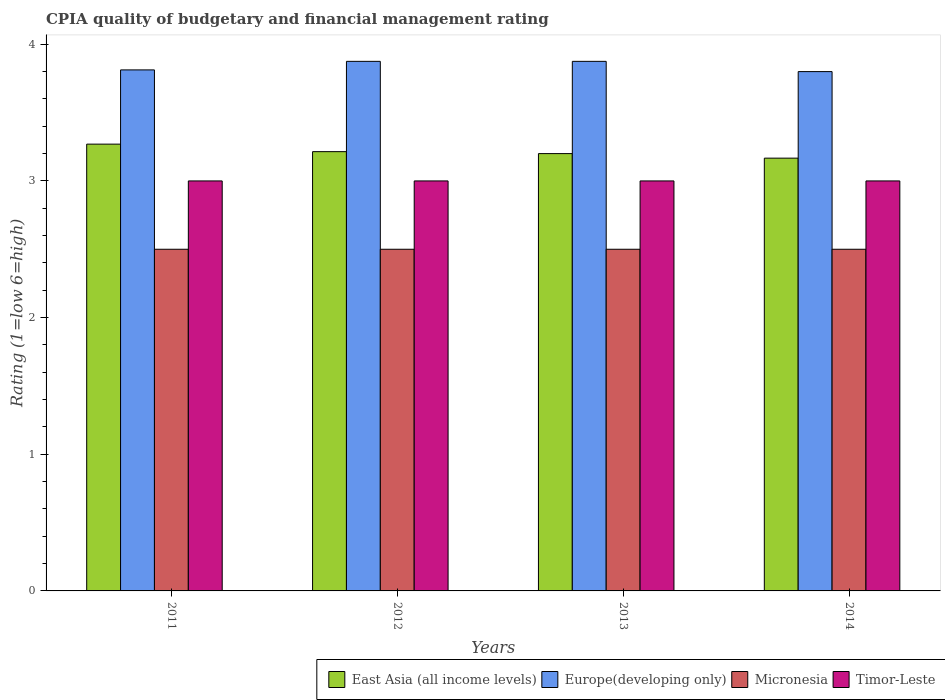How many groups of bars are there?
Offer a very short reply. 4. How many bars are there on the 1st tick from the left?
Offer a terse response. 4. What is the label of the 2nd group of bars from the left?
Offer a terse response. 2012. In how many cases, is the number of bars for a given year not equal to the number of legend labels?
Offer a very short reply. 0. What is the CPIA rating in East Asia (all income levels) in 2011?
Keep it short and to the point. 3.27. Across all years, what is the maximum CPIA rating in Micronesia?
Give a very brief answer. 2.5. Across all years, what is the minimum CPIA rating in Micronesia?
Give a very brief answer. 2.5. In which year was the CPIA rating in East Asia (all income levels) maximum?
Your answer should be compact. 2011. In which year was the CPIA rating in Timor-Leste minimum?
Make the answer very short. 2011. What is the total CPIA rating in Europe(developing only) in the graph?
Offer a terse response. 15.36. What is the difference between the CPIA rating in East Asia (all income levels) in 2014 and the CPIA rating in Timor-Leste in 2012?
Give a very brief answer. 0.17. What is the average CPIA rating in Europe(developing only) per year?
Ensure brevity in your answer.  3.84. In how many years, is the CPIA rating in Timor-Leste greater than 0.2?
Offer a very short reply. 4. What is the ratio of the CPIA rating in East Asia (all income levels) in 2012 to that in 2014?
Offer a terse response. 1.02. Is the CPIA rating in Micronesia in 2012 less than that in 2013?
Offer a very short reply. No. Is the difference between the CPIA rating in Europe(developing only) in 2012 and 2014 greater than the difference between the CPIA rating in Timor-Leste in 2012 and 2014?
Your answer should be compact. Yes. What is the difference between the highest and the lowest CPIA rating in East Asia (all income levels)?
Provide a succinct answer. 0.1. In how many years, is the CPIA rating in Europe(developing only) greater than the average CPIA rating in Europe(developing only) taken over all years?
Offer a terse response. 2. What does the 2nd bar from the left in 2011 represents?
Give a very brief answer. Europe(developing only). What does the 3rd bar from the right in 2012 represents?
Offer a terse response. Europe(developing only). Is it the case that in every year, the sum of the CPIA rating in Timor-Leste and CPIA rating in Micronesia is greater than the CPIA rating in East Asia (all income levels)?
Your response must be concise. Yes. How many bars are there?
Your response must be concise. 16. What is the difference between two consecutive major ticks on the Y-axis?
Your answer should be very brief. 1. Does the graph contain grids?
Offer a very short reply. No. How many legend labels are there?
Provide a succinct answer. 4. What is the title of the graph?
Give a very brief answer. CPIA quality of budgetary and financial management rating. What is the label or title of the X-axis?
Your response must be concise. Years. What is the label or title of the Y-axis?
Your response must be concise. Rating (1=low 6=high). What is the Rating (1=low 6=high) in East Asia (all income levels) in 2011?
Keep it short and to the point. 3.27. What is the Rating (1=low 6=high) of Europe(developing only) in 2011?
Ensure brevity in your answer.  3.81. What is the Rating (1=low 6=high) in East Asia (all income levels) in 2012?
Keep it short and to the point. 3.21. What is the Rating (1=low 6=high) of Europe(developing only) in 2012?
Offer a very short reply. 3.88. What is the Rating (1=low 6=high) of Timor-Leste in 2012?
Your answer should be compact. 3. What is the Rating (1=low 6=high) of Europe(developing only) in 2013?
Your response must be concise. 3.88. What is the Rating (1=low 6=high) of East Asia (all income levels) in 2014?
Keep it short and to the point. 3.17. What is the Rating (1=low 6=high) of Europe(developing only) in 2014?
Give a very brief answer. 3.8. What is the Rating (1=low 6=high) in Micronesia in 2014?
Provide a succinct answer. 2.5. What is the Rating (1=low 6=high) in Timor-Leste in 2014?
Your answer should be very brief. 3. Across all years, what is the maximum Rating (1=low 6=high) of East Asia (all income levels)?
Ensure brevity in your answer.  3.27. Across all years, what is the maximum Rating (1=low 6=high) in Europe(developing only)?
Offer a terse response. 3.88. Across all years, what is the maximum Rating (1=low 6=high) in Micronesia?
Ensure brevity in your answer.  2.5. Across all years, what is the maximum Rating (1=low 6=high) of Timor-Leste?
Make the answer very short. 3. Across all years, what is the minimum Rating (1=low 6=high) in East Asia (all income levels)?
Your answer should be very brief. 3.17. Across all years, what is the minimum Rating (1=low 6=high) in Europe(developing only)?
Your answer should be very brief. 3.8. What is the total Rating (1=low 6=high) in East Asia (all income levels) in the graph?
Provide a short and direct response. 12.85. What is the total Rating (1=low 6=high) of Europe(developing only) in the graph?
Offer a terse response. 15.36. What is the total Rating (1=low 6=high) in Micronesia in the graph?
Offer a very short reply. 10. What is the total Rating (1=low 6=high) of Timor-Leste in the graph?
Provide a succinct answer. 12. What is the difference between the Rating (1=low 6=high) of East Asia (all income levels) in 2011 and that in 2012?
Ensure brevity in your answer.  0.05. What is the difference between the Rating (1=low 6=high) of Europe(developing only) in 2011 and that in 2012?
Your answer should be very brief. -0.06. What is the difference between the Rating (1=low 6=high) of Micronesia in 2011 and that in 2012?
Make the answer very short. 0. What is the difference between the Rating (1=low 6=high) of East Asia (all income levels) in 2011 and that in 2013?
Ensure brevity in your answer.  0.07. What is the difference between the Rating (1=low 6=high) in Europe(developing only) in 2011 and that in 2013?
Your response must be concise. -0.06. What is the difference between the Rating (1=low 6=high) of Micronesia in 2011 and that in 2013?
Offer a very short reply. 0. What is the difference between the Rating (1=low 6=high) in East Asia (all income levels) in 2011 and that in 2014?
Offer a very short reply. 0.1. What is the difference between the Rating (1=low 6=high) in Europe(developing only) in 2011 and that in 2014?
Your answer should be very brief. 0.01. What is the difference between the Rating (1=low 6=high) of Micronesia in 2011 and that in 2014?
Offer a very short reply. 0. What is the difference between the Rating (1=low 6=high) of East Asia (all income levels) in 2012 and that in 2013?
Keep it short and to the point. 0.01. What is the difference between the Rating (1=low 6=high) of Micronesia in 2012 and that in 2013?
Provide a succinct answer. 0. What is the difference between the Rating (1=low 6=high) of Timor-Leste in 2012 and that in 2013?
Provide a succinct answer. 0. What is the difference between the Rating (1=low 6=high) of East Asia (all income levels) in 2012 and that in 2014?
Offer a terse response. 0.05. What is the difference between the Rating (1=low 6=high) in Europe(developing only) in 2012 and that in 2014?
Ensure brevity in your answer.  0.07. What is the difference between the Rating (1=low 6=high) in Europe(developing only) in 2013 and that in 2014?
Your response must be concise. 0.07. What is the difference between the Rating (1=low 6=high) in East Asia (all income levels) in 2011 and the Rating (1=low 6=high) in Europe(developing only) in 2012?
Provide a short and direct response. -0.61. What is the difference between the Rating (1=low 6=high) in East Asia (all income levels) in 2011 and the Rating (1=low 6=high) in Micronesia in 2012?
Your answer should be very brief. 0.77. What is the difference between the Rating (1=low 6=high) in East Asia (all income levels) in 2011 and the Rating (1=low 6=high) in Timor-Leste in 2012?
Provide a short and direct response. 0.27. What is the difference between the Rating (1=low 6=high) of Europe(developing only) in 2011 and the Rating (1=low 6=high) of Micronesia in 2012?
Offer a very short reply. 1.31. What is the difference between the Rating (1=low 6=high) in Europe(developing only) in 2011 and the Rating (1=low 6=high) in Timor-Leste in 2012?
Keep it short and to the point. 0.81. What is the difference between the Rating (1=low 6=high) of East Asia (all income levels) in 2011 and the Rating (1=low 6=high) of Europe(developing only) in 2013?
Give a very brief answer. -0.61. What is the difference between the Rating (1=low 6=high) in East Asia (all income levels) in 2011 and the Rating (1=low 6=high) in Micronesia in 2013?
Your answer should be very brief. 0.77. What is the difference between the Rating (1=low 6=high) in East Asia (all income levels) in 2011 and the Rating (1=low 6=high) in Timor-Leste in 2013?
Give a very brief answer. 0.27. What is the difference between the Rating (1=low 6=high) of Europe(developing only) in 2011 and the Rating (1=low 6=high) of Micronesia in 2013?
Your response must be concise. 1.31. What is the difference between the Rating (1=low 6=high) of Europe(developing only) in 2011 and the Rating (1=low 6=high) of Timor-Leste in 2013?
Offer a very short reply. 0.81. What is the difference between the Rating (1=low 6=high) of Micronesia in 2011 and the Rating (1=low 6=high) of Timor-Leste in 2013?
Offer a terse response. -0.5. What is the difference between the Rating (1=low 6=high) in East Asia (all income levels) in 2011 and the Rating (1=low 6=high) in Europe(developing only) in 2014?
Ensure brevity in your answer.  -0.53. What is the difference between the Rating (1=low 6=high) in East Asia (all income levels) in 2011 and the Rating (1=low 6=high) in Micronesia in 2014?
Keep it short and to the point. 0.77. What is the difference between the Rating (1=low 6=high) in East Asia (all income levels) in 2011 and the Rating (1=low 6=high) in Timor-Leste in 2014?
Provide a short and direct response. 0.27. What is the difference between the Rating (1=low 6=high) of Europe(developing only) in 2011 and the Rating (1=low 6=high) of Micronesia in 2014?
Ensure brevity in your answer.  1.31. What is the difference between the Rating (1=low 6=high) in Europe(developing only) in 2011 and the Rating (1=low 6=high) in Timor-Leste in 2014?
Give a very brief answer. 0.81. What is the difference between the Rating (1=low 6=high) of Micronesia in 2011 and the Rating (1=low 6=high) of Timor-Leste in 2014?
Provide a succinct answer. -0.5. What is the difference between the Rating (1=low 6=high) of East Asia (all income levels) in 2012 and the Rating (1=low 6=high) of Europe(developing only) in 2013?
Your response must be concise. -0.66. What is the difference between the Rating (1=low 6=high) in East Asia (all income levels) in 2012 and the Rating (1=low 6=high) in Micronesia in 2013?
Your response must be concise. 0.71. What is the difference between the Rating (1=low 6=high) of East Asia (all income levels) in 2012 and the Rating (1=low 6=high) of Timor-Leste in 2013?
Give a very brief answer. 0.21. What is the difference between the Rating (1=low 6=high) of Europe(developing only) in 2012 and the Rating (1=low 6=high) of Micronesia in 2013?
Offer a very short reply. 1.38. What is the difference between the Rating (1=low 6=high) in Europe(developing only) in 2012 and the Rating (1=low 6=high) in Timor-Leste in 2013?
Provide a short and direct response. 0.88. What is the difference between the Rating (1=low 6=high) in Micronesia in 2012 and the Rating (1=low 6=high) in Timor-Leste in 2013?
Make the answer very short. -0.5. What is the difference between the Rating (1=low 6=high) of East Asia (all income levels) in 2012 and the Rating (1=low 6=high) of Europe(developing only) in 2014?
Your answer should be compact. -0.59. What is the difference between the Rating (1=low 6=high) in East Asia (all income levels) in 2012 and the Rating (1=low 6=high) in Timor-Leste in 2014?
Provide a short and direct response. 0.21. What is the difference between the Rating (1=low 6=high) of Europe(developing only) in 2012 and the Rating (1=low 6=high) of Micronesia in 2014?
Your answer should be compact. 1.38. What is the difference between the Rating (1=low 6=high) of Europe(developing only) in 2012 and the Rating (1=low 6=high) of Timor-Leste in 2014?
Your answer should be very brief. 0.88. What is the difference between the Rating (1=low 6=high) in East Asia (all income levels) in 2013 and the Rating (1=low 6=high) in Micronesia in 2014?
Provide a short and direct response. 0.7. What is the difference between the Rating (1=low 6=high) of East Asia (all income levels) in 2013 and the Rating (1=low 6=high) of Timor-Leste in 2014?
Give a very brief answer. 0.2. What is the difference between the Rating (1=low 6=high) of Europe(developing only) in 2013 and the Rating (1=low 6=high) of Micronesia in 2014?
Give a very brief answer. 1.38. What is the average Rating (1=low 6=high) in East Asia (all income levels) per year?
Provide a short and direct response. 3.21. What is the average Rating (1=low 6=high) of Europe(developing only) per year?
Your response must be concise. 3.84. What is the average Rating (1=low 6=high) of Micronesia per year?
Your response must be concise. 2.5. What is the average Rating (1=low 6=high) of Timor-Leste per year?
Offer a terse response. 3. In the year 2011, what is the difference between the Rating (1=low 6=high) of East Asia (all income levels) and Rating (1=low 6=high) of Europe(developing only)?
Offer a terse response. -0.54. In the year 2011, what is the difference between the Rating (1=low 6=high) of East Asia (all income levels) and Rating (1=low 6=high) of Micronesia?
Give a very brief answer. 0.77. In the year 2011, what is the difference between the Rating (1=low 6=high) in East Asia (all income levels) and Rating (1=low 6=high) in Timor-Leste?
Offer a terse response. 0.27. In the year 2011, what is the difference between the Rating (1=low 6=high) of Europe(developing only) and Rating (1=low 6=high) of Micronesia?
Your response must be concise. 1.31. In the year 2011, what is the difference between the Rating (1=low 6=high) of Europe(developing only) and Rating (1=low 6=high) of Timor-Leste?
Offer a very short reply. 0.81. In the year 2012, what is the difference between the Rating (1=low 6=high) in East Asia (all income levels) and Rating (1=low 6=high) in Europe(developing only)?
Your response must be concise. -0.66. In the year 2012, what is the difference between the Rating (1=low 6=high) in East Asia (all income levels) and Rating (1=low 6=high) in Micronesia?
Make the answer very short. 0.71. In the year 2012, what is the difference between the Rating (1=low 6=high) of East Asia (all income levels) and Rating (1=low 6=high) of Timor-Leste?
Provide a short and direct response. 0.21. In the year 2012, what is the difference between the Rating (1=low 6=high) of Europe(developing only) and Rating (1=low 6=high) of Micronesia?
Give a very brief answer. 1.38. In the year 2013, what is the difference between the Rating (1=low 6=high) in East Asia (all income levels) and Rating (1=low 6=high) in Europe(developing only)?
Offer a terse response. -0.68. In the year 2013, what is the difference between the Rating (1=low 6=high) of East Asia (all income levels) and Rating (1=low 6=high) of Timor-Leste?
Ensure brevity in your answer.  0.2. In the year 2013, what is the difference between the Rating (1=low 6=high) in Europe(developing only) and Rating (1=low 6=high) in Micronesia?
Give a very brief answer. 1.38. In the year 2014, what is the difference between the Rating (1=low 6=high) in East Asia (all income levels) and Rating (1=low 6=high) in Europe(developing only)?
Offer a very short reply. -0.63. In the year 2014, what is the difference between the Rating (1=low 6=high) in Europe(developing only) and Rating (1=low 6=high) in Micronesia?
Give a very brief answer. 1.3. In the year 2014, what is the difference between the Rating (1=low 6=high) of Europe(developing only) and Rating (1=low 6=high) of Timor-Leste?
Give a very brief answer. 0.8. In the year 2014, what is the difference between the Rating (1=low 6=high) in Micronesia and Rating (1=low 6=high) in Timor-Leste?
Provide a short and direct response. -0.5. What is the ratio of the Rating (1=low 6=high) in East Asia (all income levels) in 2011 to that in 2012?
Ensure brevity in your answer.  1.02. What is the ratio of the Rating (1=low 6=high) of Europe(developing only) in 2011 to that in 2012?
Keep it short and to the point. 0.98. What is the ratio of the Rating (1=low 6=high) of Timor-Leste in 2011 to that in 2012?
Offer a very short reply. 1. What is the ratio of the Rating (1=low 6=high) of East Asia (all income levels) in 2011 to that in 2013?
Make the answer very short. 1.02. What is the ratio of the Rating (1=low 6=high) of Europe(developing only) in 2011 to that in 2013?
Offer a terse response. 0.98. What is the ratio of the Rating (1=low 6=high) of Micronesia in 2011 to that in 2013?
Offer a very short reply. 1. What is the ratio of the Rating (1=low 6=high) of Timor-Leste in 2011 to that in 2013?
Your answer should be compact. 1. What is the ratio of the Rating (1=low 6=high) of East Asia (all income levels) in 2011 to that in 2014?
Keep it short and to the point. 1.03. What is the ratio of the Rating (1=low 6=high) in Europe(developing only) in 2011 to that in 2014?
Your response must be concise. 1. What is the ratio of the Rating (1=low 6=high) in Timor-Leste in 2011 to that in 2014?
Provide a short and direct response. 1. What is the ratio of the Rating (1=low 6=high) in East Asia (all income levels) in 2012 to that in 2013?
Your answer should be very brief. 1. What is the ratio of the Rating (1=low 6=high) of Europe(developing only) in 2012 to that in 2013?
Your response must be concise. 1. What is the ratio of the Rating (1=low 6=high) of Micronesia in 2012 to that in 2013?
Ensure brevity in your answer.  1. What is the ratio of the Rating (1=low 6=high) in Timor-Leste in 2012 to that in 2013?
Offer a very short reply. 1. What is the ratio of the Rating (1=low 6=high) in East Asia (all income levels) in 2012 to that in 2014?
Your response must be concise. 1.01. What is the ratio of the Rating (1=low 6=high) of Europe(developing only) in 2012 to that in 2014?
Your answer should be very brief. 1.02. What is the ratio of the Rating (1=low 6=high) of Micronesia in 2012 to that in 2014?
Your answer should be very brief. 1. What is the ratio of the Rating (1=low 6=high) of East Asia (all income levels) in 2013 to that in 2014?
Offer a very short reply. 1.01. What is the ratio of the Rating (1=low 6=high) in Europe(developing only) in 2013 to that in 2014?
Your answer should be very brief. 1.02. What is the difference between the highest and the second highest Rating (1=low 6=high) of East Asia (all income levels)?
Your response must be concise. 0.05. What is the difference between the highest and the second highest Rating (1=low 6=high) in Europe(developing only)?
Keep it short and to the point. 0. What is the difference between the highest and the second highest Rating (1=low 6=high) of Timor-Leste?
Give a very brief answer. 0. What is the difference between the highest and the lowest Rating (1=low 6=high) of East Asia (all income levels)?
Provide a short and direct response. 0.1. What is the difference between the highest and the lowest Rating (1=low 6=high) of Europe(developing only)?
Offer a terse response. 0.07. 